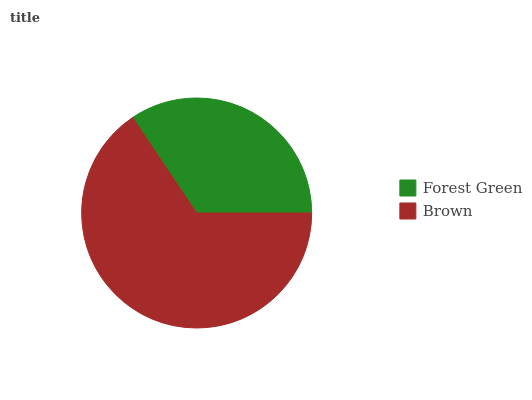Is Forest Green the minimum?
Answer yes or no. Yes. Is Brown the maximum?
Answer yes or no. Yes. Is Brown the minimum?
Answer yes or no. No. Is Brown greater than Forest Green?
Answer yes or no. Yes. Is Forest Green less than Brown?
Answer yes or no. Yes. Is Forest Green greater than Brown?
Answer yes or no. No. Is Brown less than Forest Green?
Answer yes or no. No. Is Brown the high median?
Answer yes or no. Yes. Is Forest Green the low median?
Answer yes or no. Yes. Is Forest Green the high median?
Answer yes or no. No. Is Brown the low median?
Answer yes or no. No. 